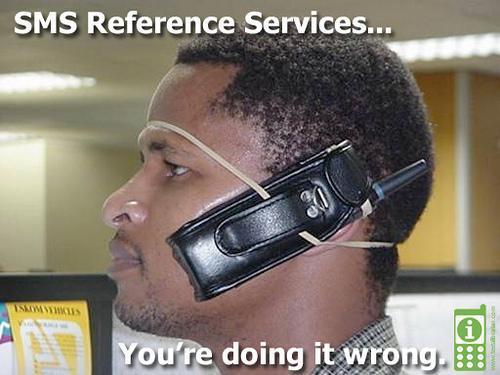How many people are in the picture?
Give a very brief answer. 1. 